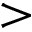<formula> <loc_0><loc_0><loc_500><loc_500>></formula> 